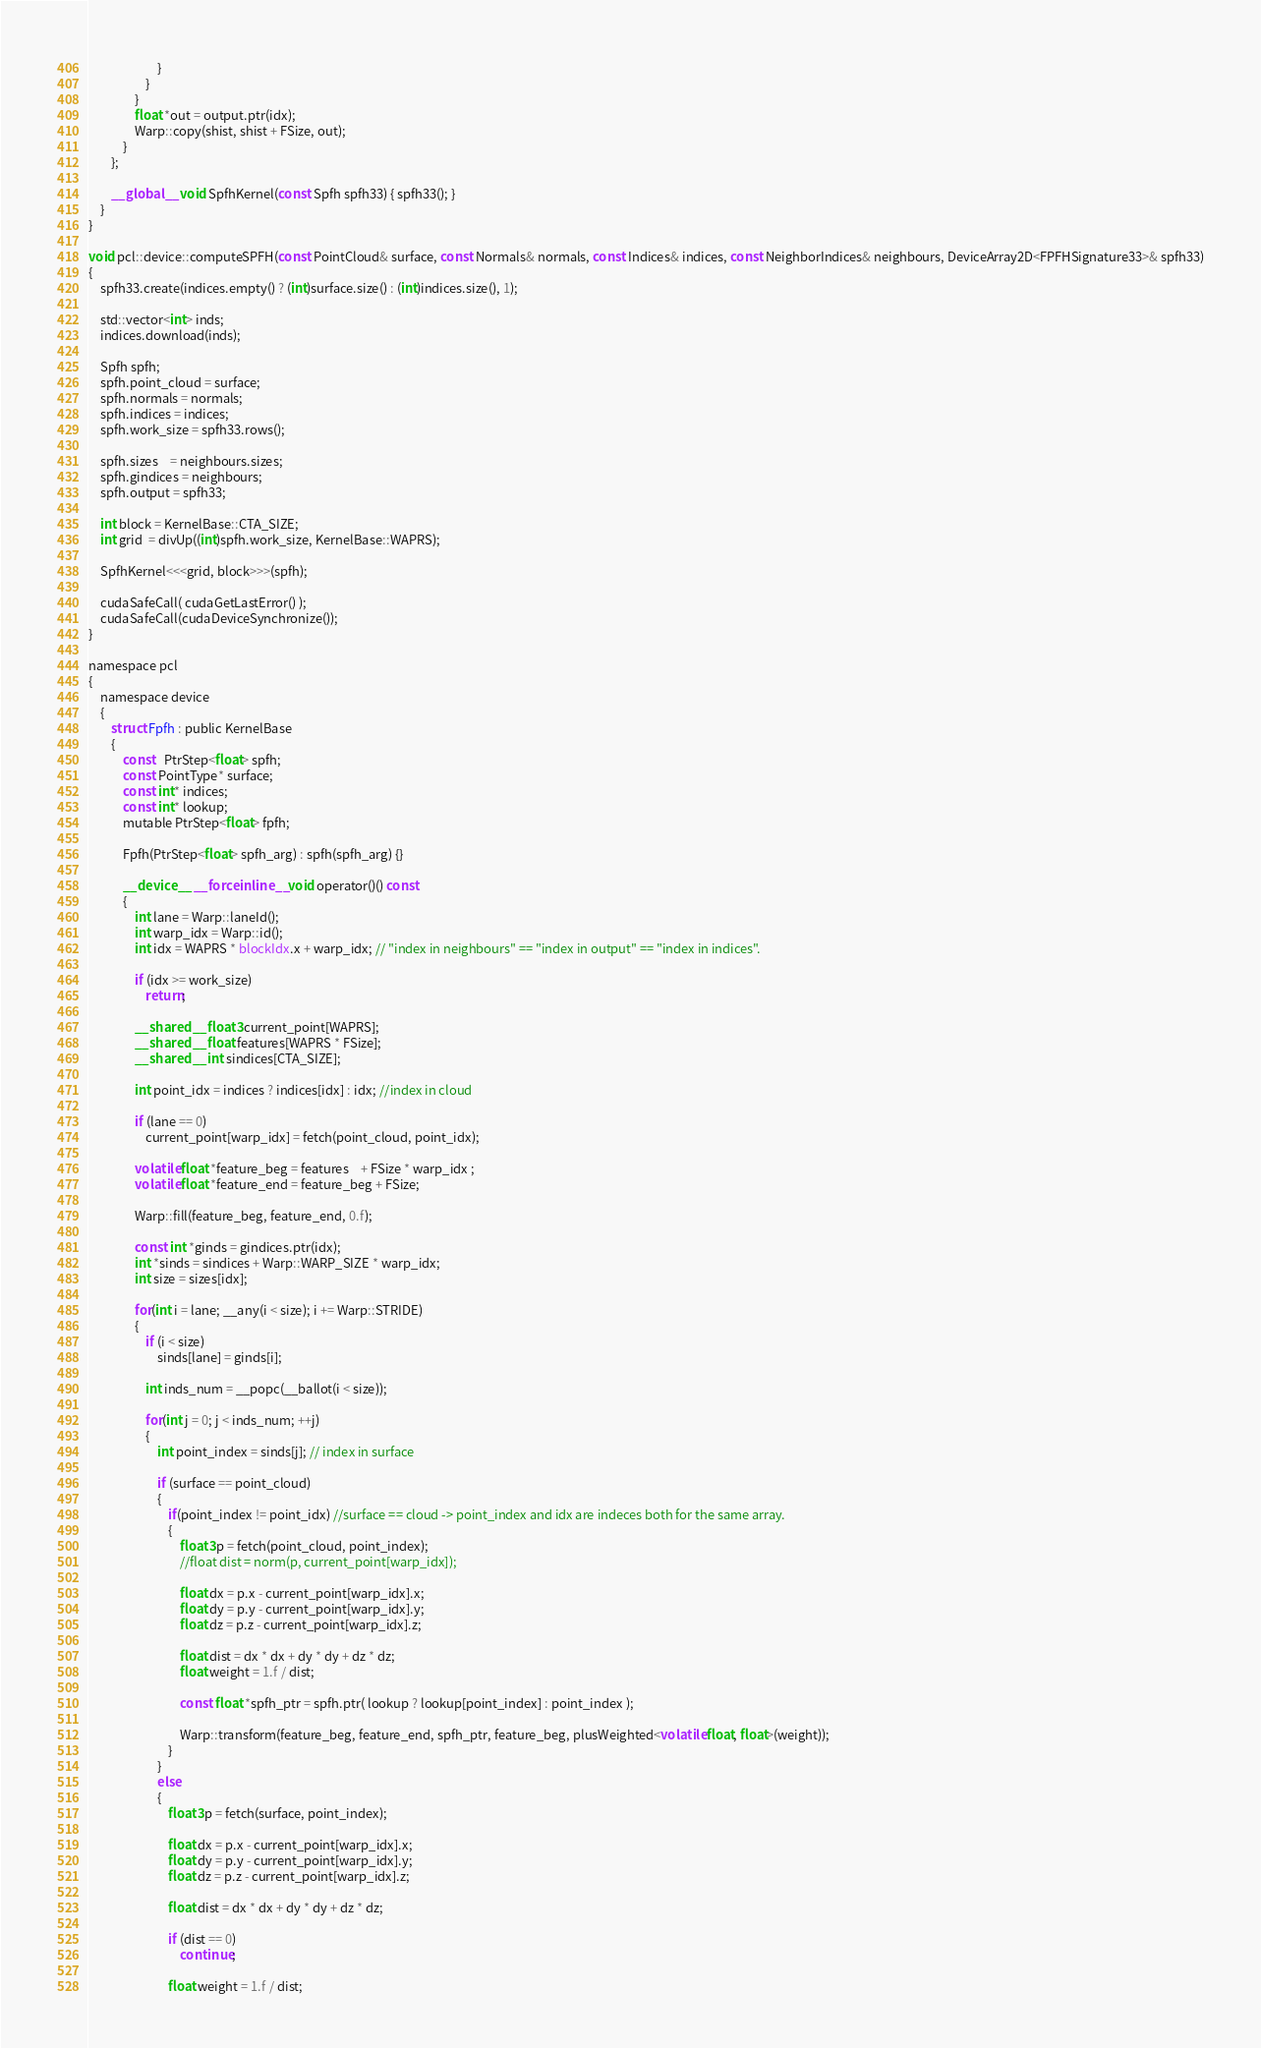Convert code to text. <code><loc_0><loc_0><loc_500><loc_500><_Cuda_>                        }
                    }
                }                
                float *out = output.ptr(idx);
                Warp::copy(shist, shist + FSize, out);
            }
        };   

        __global__ void SpfhKernel(const Spfh spfh33) { spfh33(); }
    }
}

void pcl::device::computeSPFH(const PointCloud& surface, const Normals& normals, const Indices& indices, const NeighborIndices& neighbours, DeviceArray2D<FPFHSignature33>& spfh33)
{
    spfh33.create(indices.empty() ? (int)surface.size() : (int)indices.size(), 1);

    std::vector<int> inds;
    indices.download(inds);

    Spfh spfh;
    spfh.point_cloud = surface;
    spfh.normals = normals;
    spfh.indices = indices;
    spfh.work_size = spfh33.rows();

    spfh.sizes    = neighbours.sizes;
    spfh.gindices = neighbours;    
    spfh.output = spfh33;

    int block = KernelBase::CTA_SIZE;
    int grid  = divUp((int)spfh.work_size, KernelBase::WAPRS);

    SpfhKernel<<<grid, block>>>(spfh);

    cudaSafeCall( cudaGetLastError() );        
    cudaSafeCall(cudaDeviceSynchronize());
}

namespace pcl
{
    namespace device
    {
        struct Fpfh : public KernelBase
        {   
            const   PtrStep<float> spfh;
            const PointType* surface;
            const int* indices;
            const int* lookup;
            mutable PtrStep<float> fpfh;            
            
            Fpfh(PtrStep<float> spfh_arg) : spfh(spfh_arg) {}

            __device__ __forceinline__ void operator()() const
            {                                
                int lane = Warp::laneId();                
                int warp_idx = Warp::id();    
                int idx = WAPRS * blockIdx.x + warp_idx; // "index in neighbours" == "index in output" == "index in indices".

                if (idx >= work_size)
                    return;

                __shared__ float3 current_point[WAPRS];                            
                __shared__ float features[WAPRS * FSize];
                __shared__ int sindices[CTA_SIZE];

                int point_idx = indices ? indices[idx] : idx; //index in cloud

                if (lane == 0)
                    current_point[warp_idx] = fetch(point_cloud, point_idx);

                volatile float *feature_beg = features    + FSize * warp_idx ;
                volatile float *feature_end = feature_beg + FSize;

                Warp::fill(feature_beg, feature_end, 0.f);

                const int *ginds = gindices.ptr(idx);
                int *sinds = sindices + Warp::WARP_SIZE * warp_idx;
                int size = sizes[idx];

                for(int i = lane; __any(i < size); i += Warp::STRIDE)                
                {
                    if (i < size)
                        sinds[lane] = ginds[i];

                    int inds_num = __popc(__ballot(i < size));

                    for(int j = 0; j < inds_num; ++j)
                    {
                        int point_index = sinds[j]; // index in surface
                        
                        if (surface == point_cloud)
                        {
                            if(point_index != point_idx) //surface == cloud -> point_index and idx are indeces both for the same array.
                            {                            
                                float3 p = fetch(point_cloud, point_index);                        
                                //float dist = norm(p, current_point[warp_idx]);

                                float dx = p.x - current_point[warp_idx].x;
                                float dy = p.y - current_point[warp_idx].y;
                                float dz = p.z - current_point[warp_idx].z;

                                float dist = dx * dx + dy * dy + dz * dz;
                                float weight = 1.f / dist;

                                const float *spfh_ptr = spfh.ptr( lookup ? lookup[point_index] : point_index );

                                Warp::transform(feature_beg, feature_end, spfh_ptr, feature_beg, plusWeighted<volatile float, float>(weight));
                            }
                        }
                        else
                        {
                            float3 p = fetch(surface, point_index);

                            float dx = p.x - current_point[warp_idx].x;
                            float dy = p.y - current_point[warp_idx].y;
                            float dz = p.z - current_point[warp_idx].z;

                            float dist = dx * dx + dy * dy + dz * dz;

                            if (dist == 0)
                                continue;

                            float weight = 1.f / dist;       
</code> 